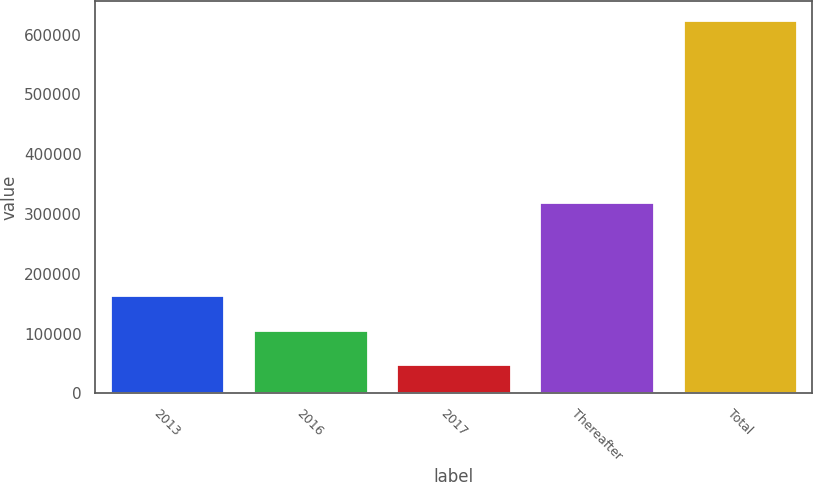Convert chart to OTSL. <chart><loc_0><loc_0><loc_500><loc_500><bar_chart><fcel>2013<fcel>2016<fcel>2017<fcel>Thereafter<fcel>Total<nl><fcel>164209<fcel>106648<fcel>49088<fcel>319415<fcel>624693<nl></chart> 